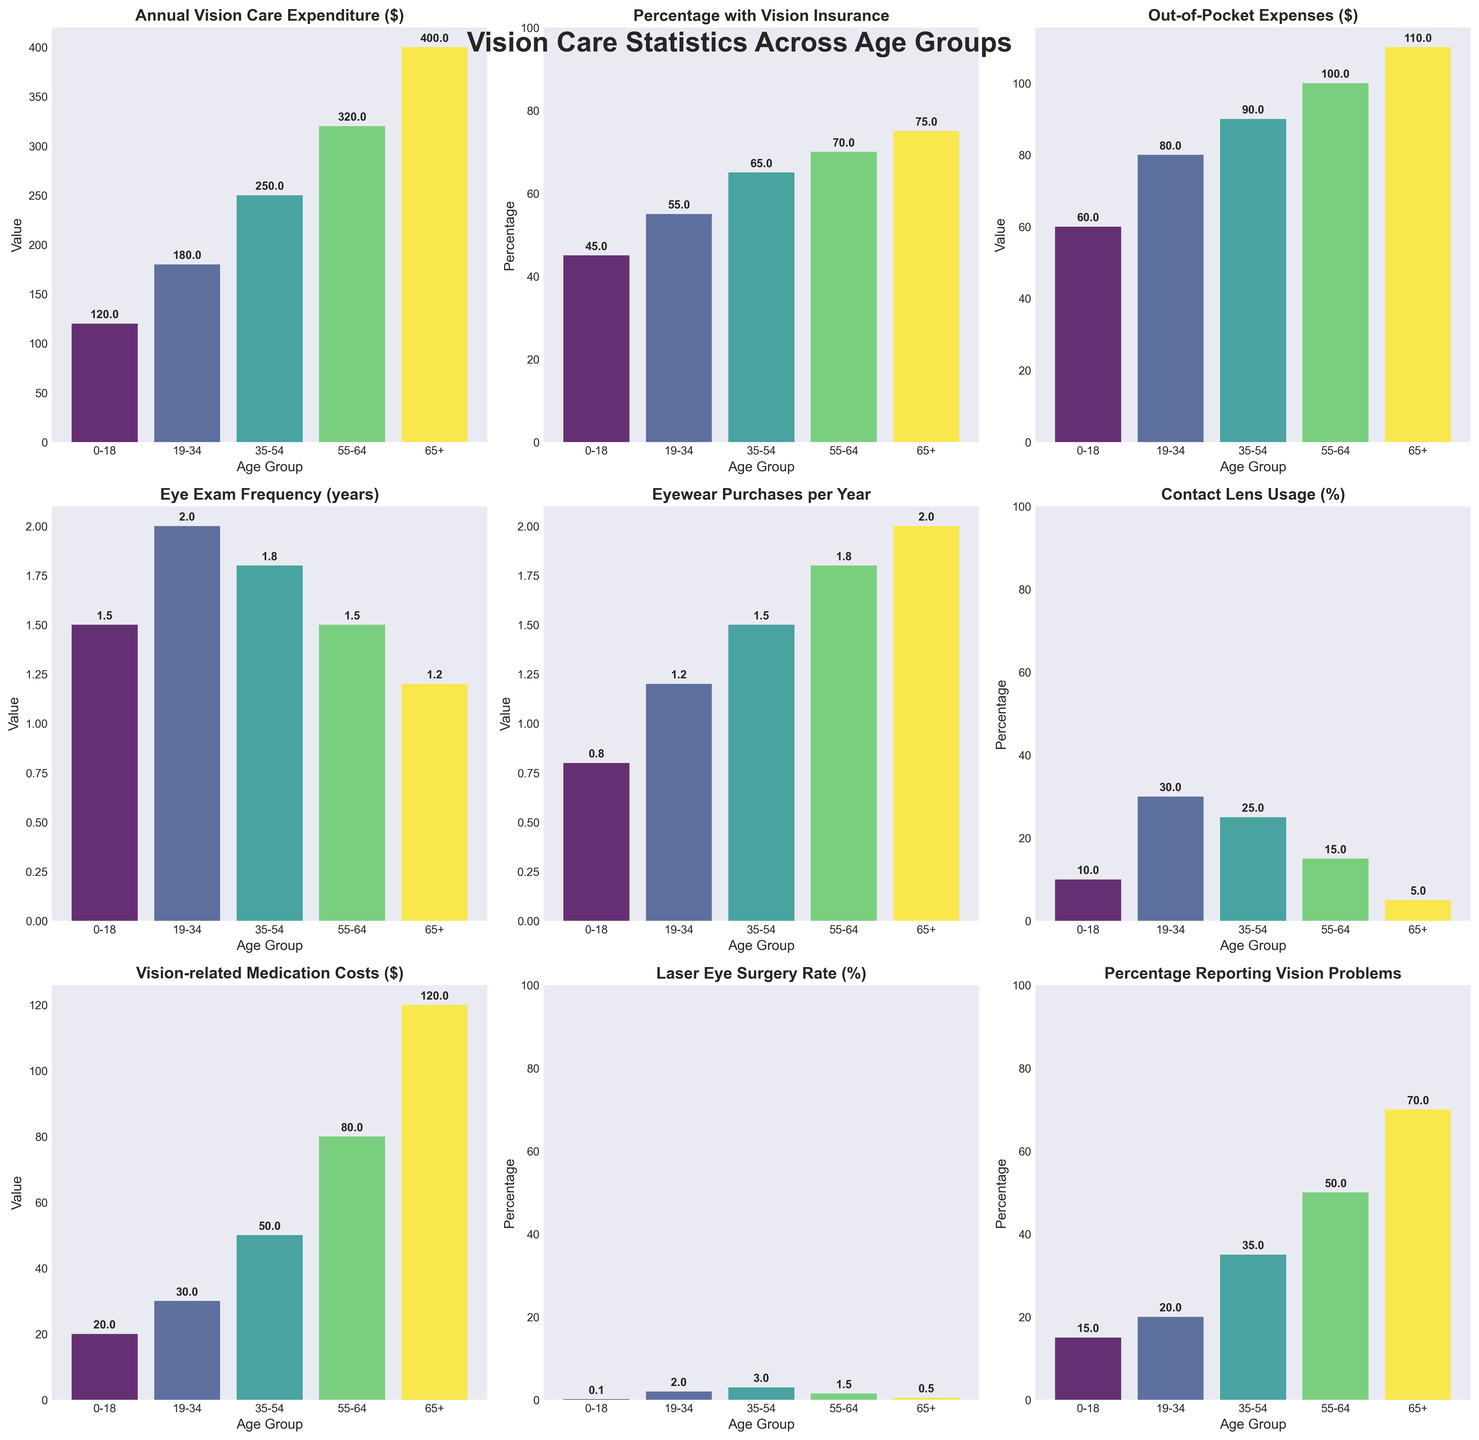What is the total Annual Vision Care Expenditure for age groups 0-18 and 55-64? To find the total, sum the expenditures for age groups 0-18 and 55-64. For 0-18, it is $120, and for 55-64, it is $320. Therefore, the total expenditure is $120 + $320 = $440.
Answer: $440 Which age group has the highest Percentage Reporting Vision Problems? To determine this, compare the Percentage Reporting Vision Problems across all age groups. The 65+ age group has the highest percentage at 70%.
Answer: 65+ How much higher is the Out-of-Pocket Expenses for the 65+ age group compared to the 0-18 age group? Subtract the Out-of-Pocket Expenses of the 0-18 age group from the 65+ age group. For 65+, it is $110, and for 0-18, it is $60. So, $110 - $60 = $50.
Answer: $50 Among the age groups, who has the most frequent Eye Exam Frequency and how often do they get their eyes checked? Identify the age group with the smallest Eye Exam Frequency value since it indicates more frequent exams. The 65+ age group has the most frequent eye exams at 1.2 years.
Answer: 65+, 1.2 years 